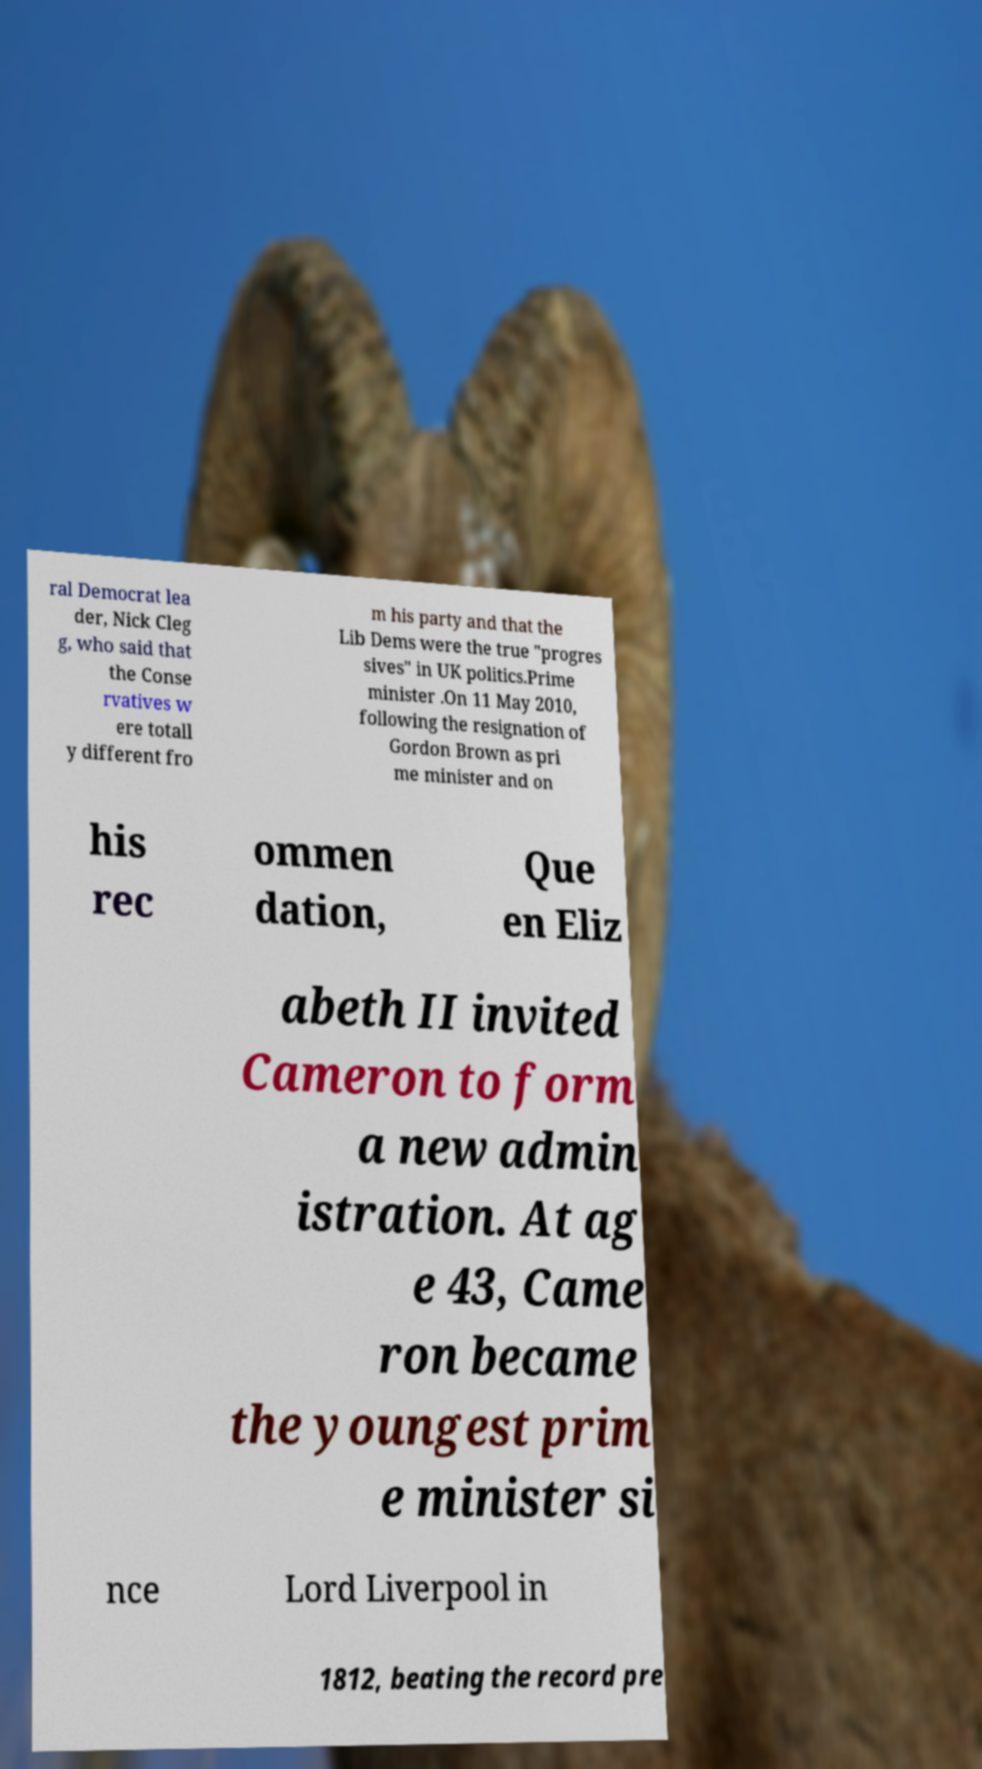Please identify and transcribe the text found in this image. ral Democrat lea der, Nick Cleg g, who said that the Conse rvatives w ere totall y different fro m his party and that the Lib Dems were the true "progres sives" in UK politics.Prime minister .On 11 May 2010, following the resignation of Gordon Brown as pri me minister and on his rec ommen dation, Que en Eliz abeth II invited Cameron to form a new admin istration. At ag e 43, Came ron became the youngest prim e minister si nce Lord Liverpool in 1812, beating the record pre 